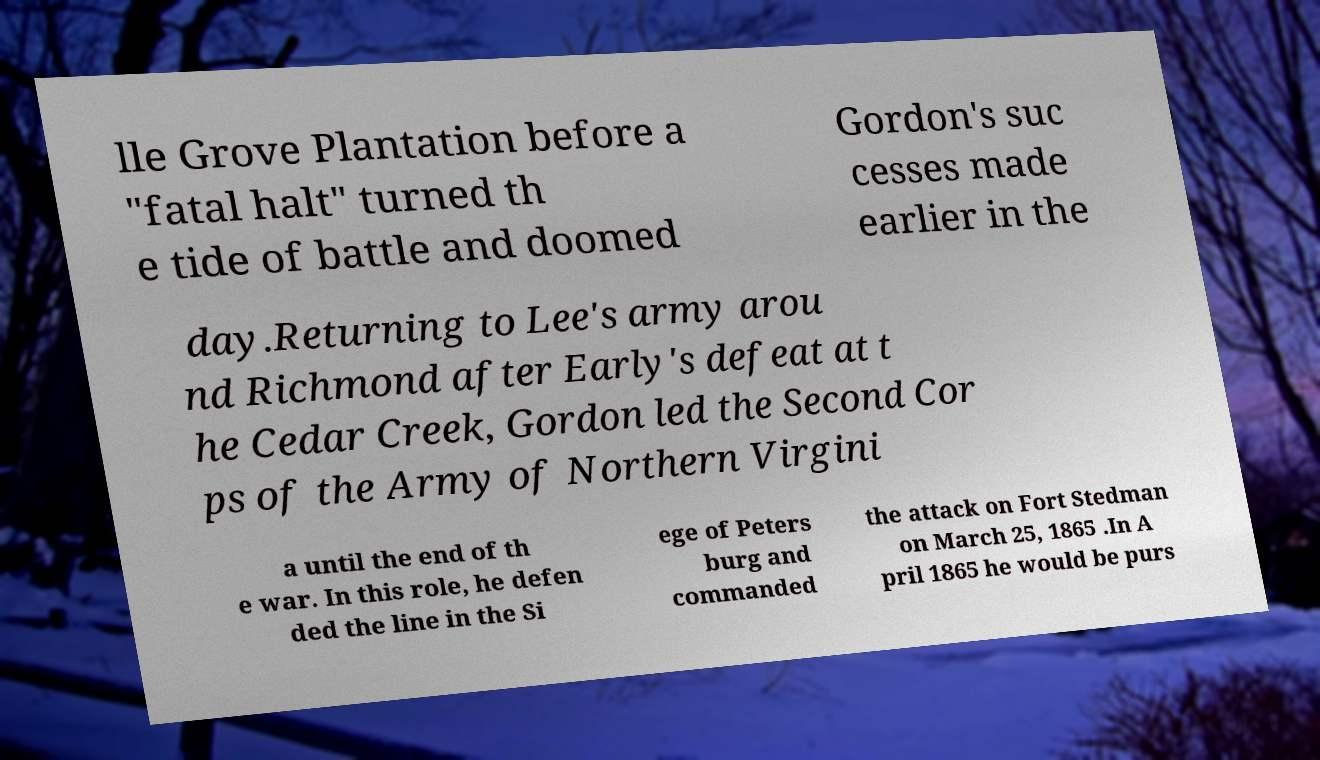Can you read and provide the text displayed in the image?This photo seems to have some interesting text. Can you extract and type it out for me? lle Grove Plantation before a "fatal halt" turned th e tide of battle and doomed Gordon's suc cesses made earlier in the day.Returning to Lee's army arou nd Richmond after Early's defeat at t he Cedar Creek, Gordon led the Second Cor ps of the Army of Northern Virgini a until the end of th e war. In this role, he defen ded the line in the Si ege of Peters burg and commanded the attack on Fort Stedman on March 25, 1865 .In A pril 1865 he would be purs 